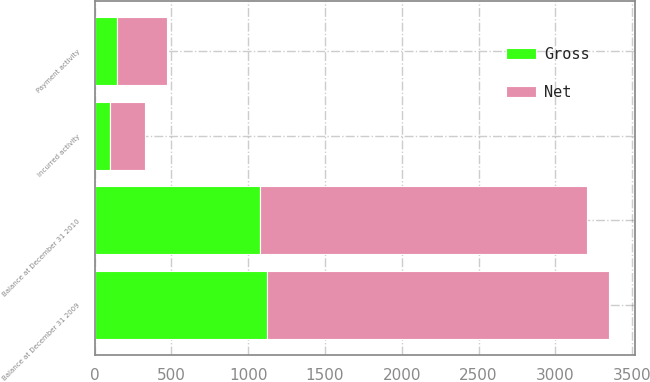<chart> <loc_0><loc_0><loc_500><loc_500><stacked_bar_chart><ecel><fcel>Balance at December 31 2009<fcel>Incurred activity<fcel>Payment activity<fcel>Balance at December 31 2010<nl><fcel>Net<fcel>2229<fcel>223<fcel>323<fcel>2130<nl><fcel>Gross<fcel>1123<fcel>103<fcel>147<fcel>1078<nl></chart> 